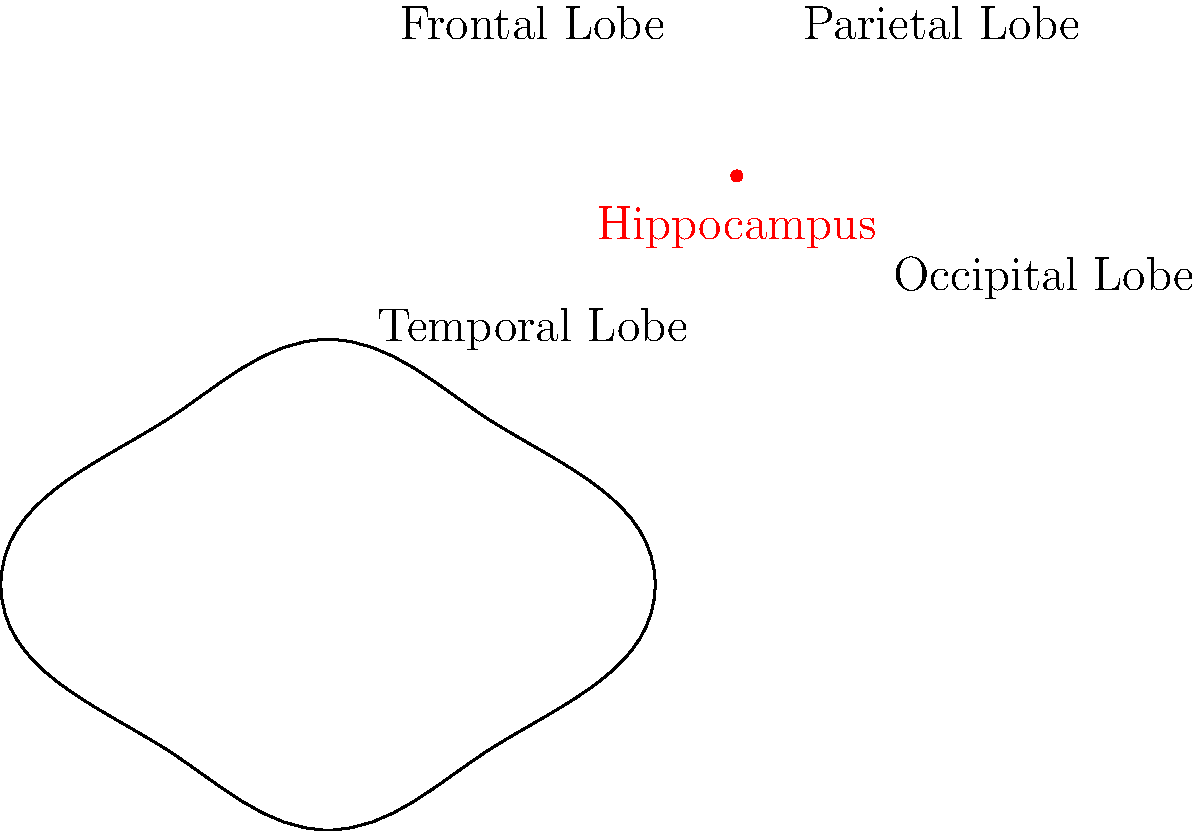In the context of epilepsy, which brain region marked in red on the diagram is particularly susceptible to seizure activity and is associated with memory formation? Explain its role in epilepsy and potential cognitive impacts. 1. The brain region marked in red on the diagram is the hippocampus.

2. The hippocampus is particularly susceptible to seizure activity in epilepsy due to its intrinsic cellular properties and network organization.

3. Role in epilepsy:
   a. The hippocampus is often the site of seizure onset in temporal lobe epilepsy (TLE), the most common form of focal epilepsy in adults.
   b. It can undergo structural changes (hippocampal sclerosis) in chronic epilepsy, further lowering the seizure threshold.

4. Cognitive impacts:
   a. The hippocampus plays a crucial role in memory formation, particularly in the consolidation of short-term memories into long-term memories.
   b. Epileptic activity in the hippocampus can disrupt these processes, leading to memory impairments.

5. Potential cognitive deficits associated with hippocampal epilepsy:
   a. Difficulties in forming new declarative memories (episodic and semantic memories)
   b. Impaired spatial memory and navigation
   c. Challenges in pattern separation and completion, affecting the ability to distinguish between similar experiences

6. The cognitive impact can vary depending on factors such as:
   a. The frequency and severity of seizures
   b. The extent of hippocampal damage
   c. The side of hippocampal involvement (left vs. right)

7. Understanding the role of the hippocampus in epilepsy is crucial for:
   a. Developing targeted treatments to reduce seizure activity
   b. Implementing cognitive rehabilitation strategies
   c. Predicting and managing potential cognitive deficits in patients with epilepsy
Answer: Hippocampus; crucial for memory formation, highly susceptible to seizures in epilepsy, causing potential cognitive impairments. 